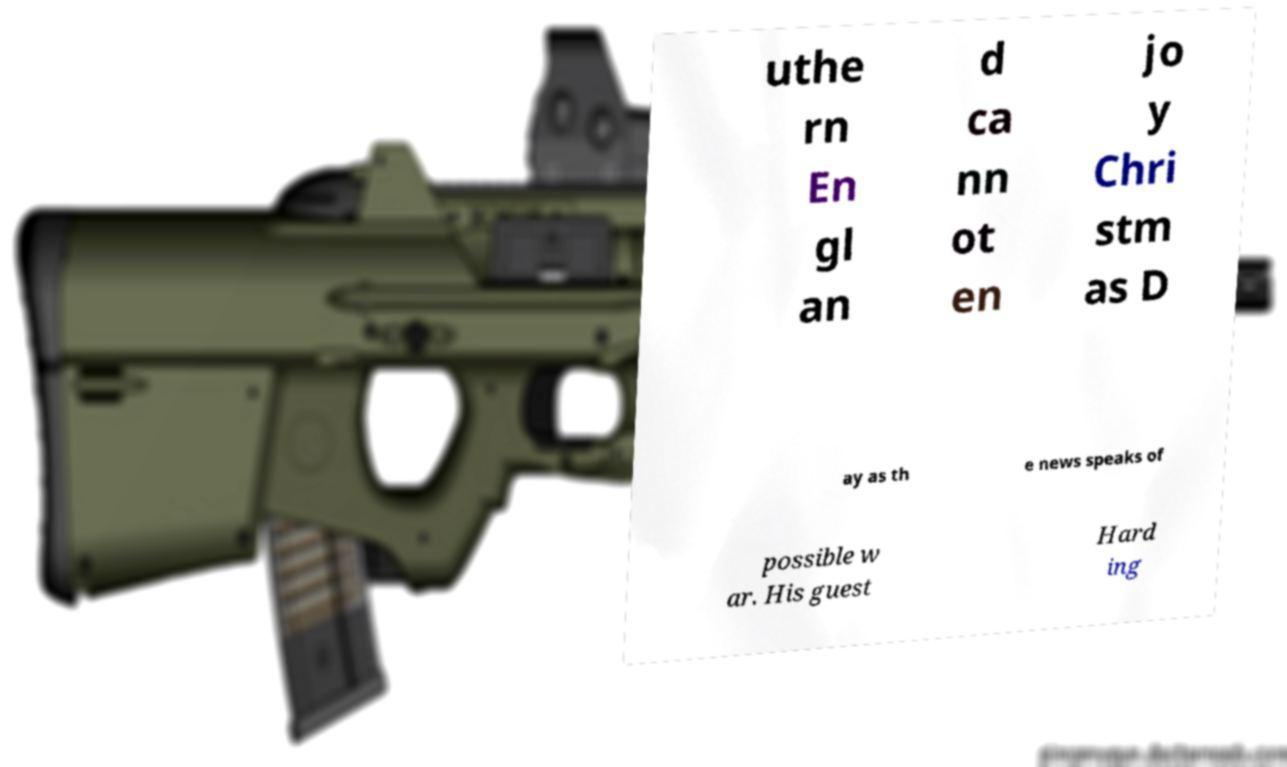For documentation purposes, I need the text within this image transcribed. Could you provide that? uthe rn En gl an d ca nn ot en jo y Chri stm as D ay as th e news speaks of possible w ar. His guest Hard ing 